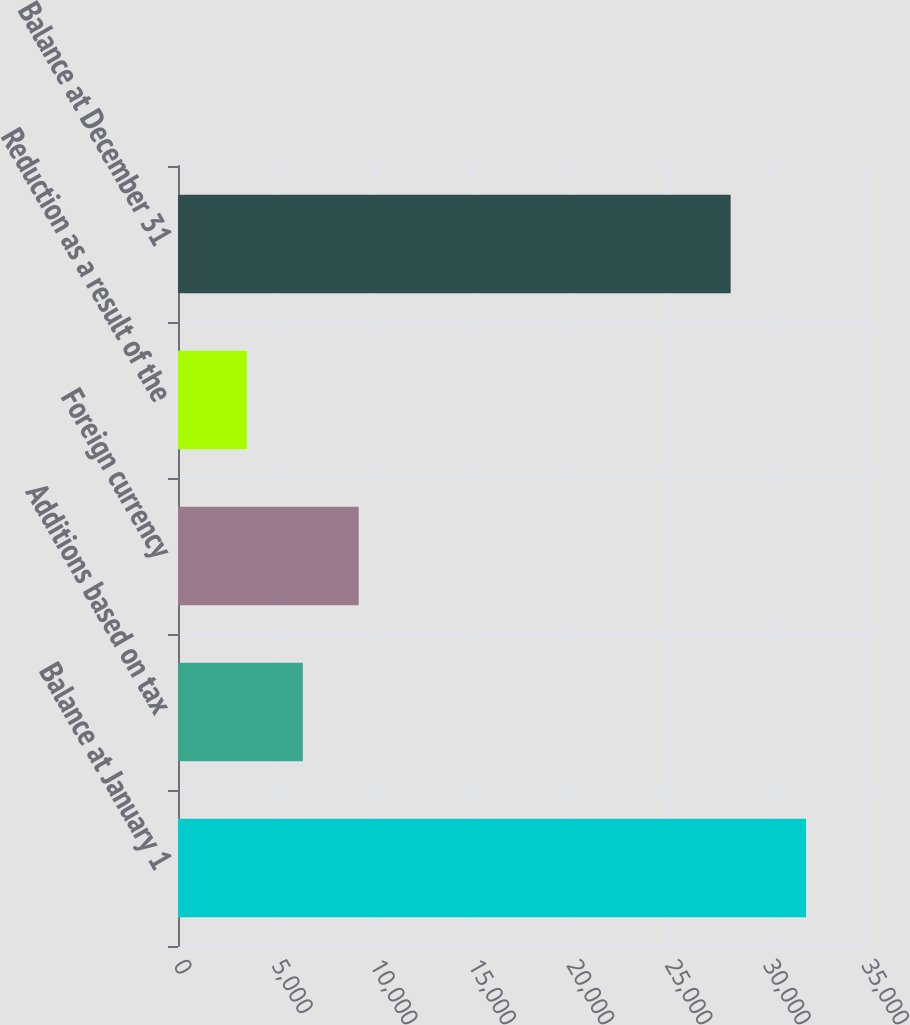Convert chart. <chart><loc_0><loc_0><loc_500><loc_500><bar_chart><fcel>Balance at January 1<fcel>Additions based on tax<fcel>Foreign currency<fcel>Reduction as a result of the<fcel>Balance at December 31<nl><fcel>31947<fcel>6348.3<fcel>9192.6<fcel>3504<fcel>28114<nl></chart> 